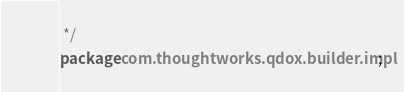Convert code to text. <code><loc_0><loc_0><loc_500><loc_500><_Java_> */
package com.thoughtworks.qdox.builder.impl;</code> 